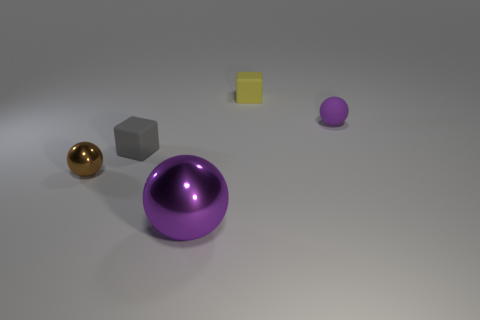Subtract all purple balls. How many balls are left? 1 Subtract 1 cubes. How many cubes are left? 1 Subtract all brown balls. How many balls are left? 2 Add 4 small brown balls. How many objects exist? 9 Subtract all balls. How many objects are left? 2 Subtract all purple cubes. How many brown balls are left? 1 Subtract all brown spheres. Subtract all yellow cylinders. How many spheres are left? 2 Subtract all tiny red shiny cylinders. Subtract all tiny cubes. How many objects are left? 3 Add 3 purple spheres. How many purple spheres are left? 5 Add 2 metallic objects. How many metallic objects exist? 4 